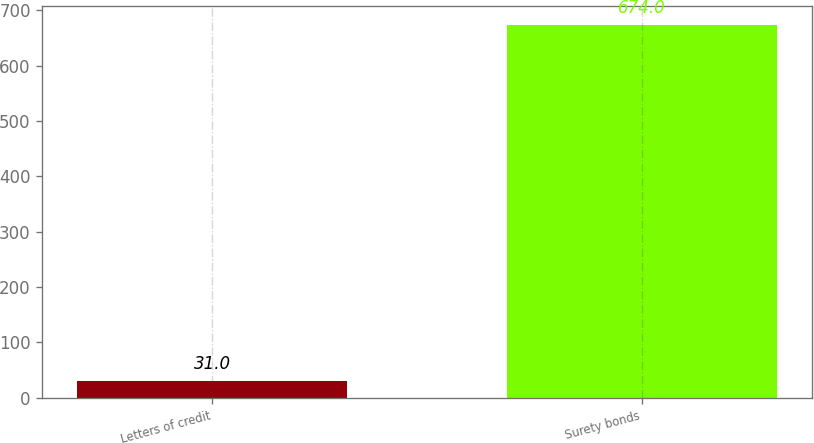<chart> <loc_0><loc_0><loc_500><loc_500><bar_chart><fcel>Letters of credit<fcel>Surety bonds<nl><fcel>31<fcel>674<nl></chart> 